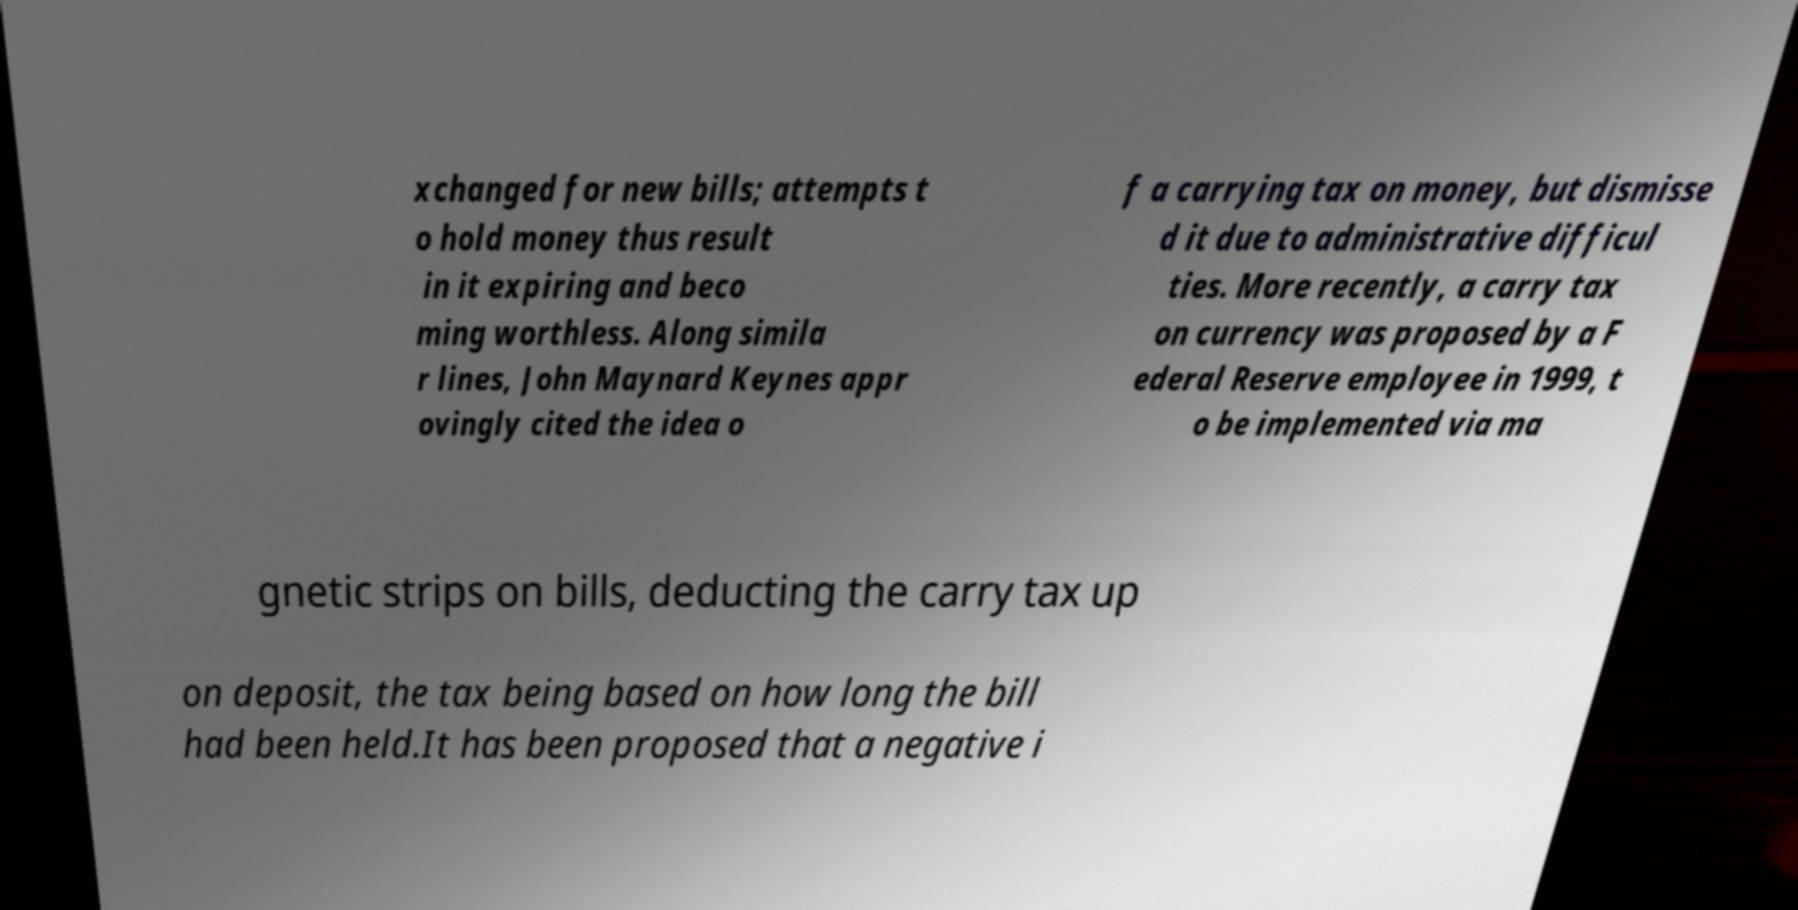Please identify and transcribe the text found in this image. xchanged for new bills; attempts t o hold money thus result in it expiring and beco ming worthless. Along simila r lines, John Maynard Keynes appr ovingly cited the idea o f a carrying tax on money, but dismisse d it due to administrative difficul ties. More recently, a carry tax on currency was proposed by a F ederal Reserve employee in 1999, t o be implemented via ma gnetic strips on bills, deducting the carry tax up on deposit, the tax being based on how long the bill had been held.It has been proposed that a negative i 